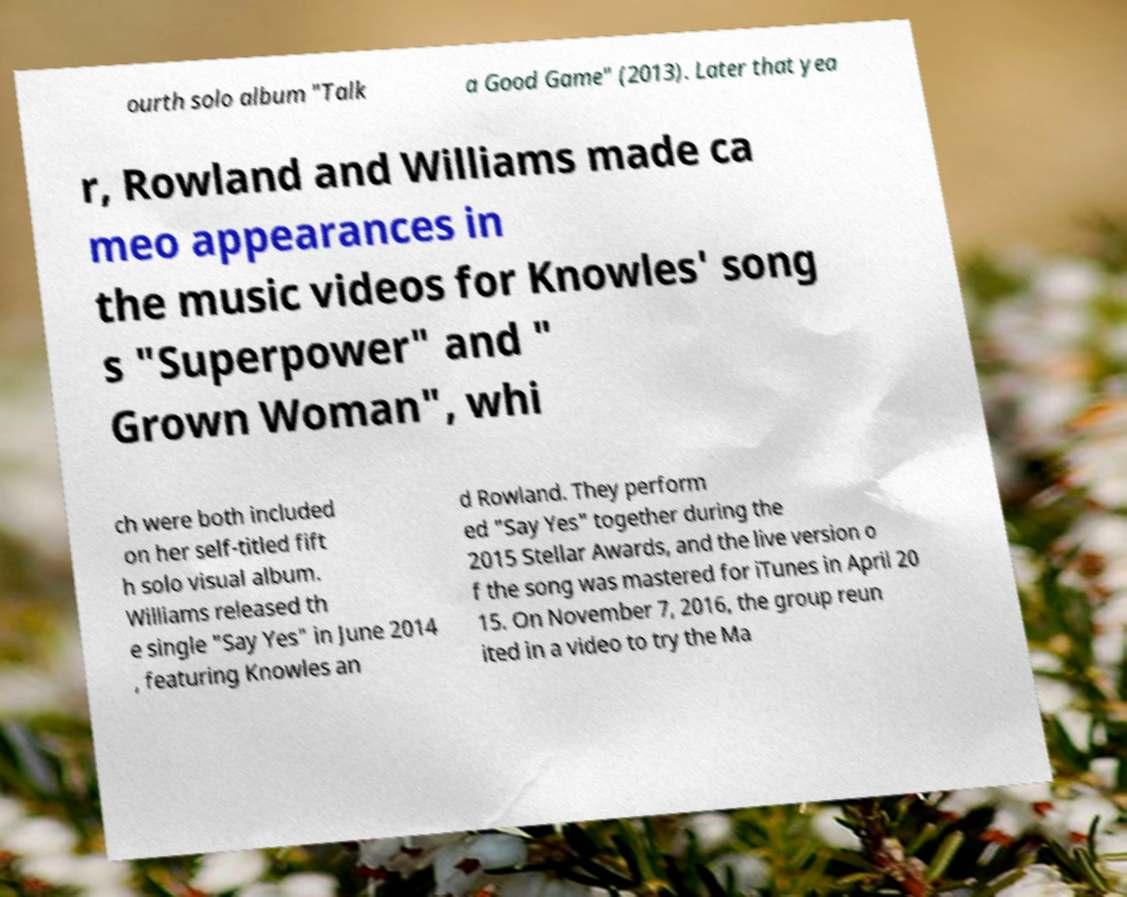For documentation purposes, I need the text within this image transcribed. Could you provide that? ourth solo album "Talk a Good Game" (2013). Later that yea r, Rowland and Williams made ca meo appearances in the music videos for Knowles' song s "Superpower" and " Grown Woman", whi ch were both included on her self-titled fift h solo visual album. Williams released th e single "Say Yes" in June 2014 , featuring Knowles an d Rowland. They perform ed "Say Yes" together during the 2015 Stellar Awards, and the live version o f the song was mastered for iTunes in April 20 15. On November 7, 2016, the group reun ited in a video to try the Ma 